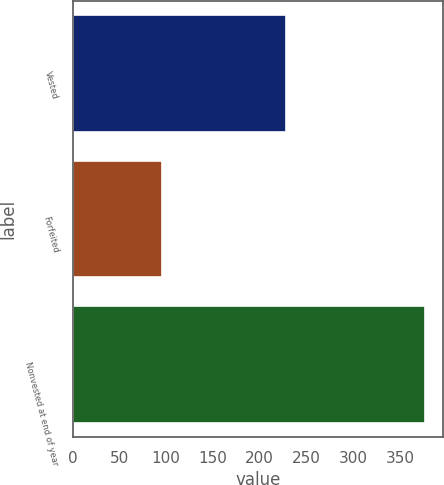Convert chart. <chart><loc_0><loc_0><loc_500><loc_500><bar_chart><fcel>Vested<fcel>Forfeited<fcel>Nonvested at end of year<nl><fcel>228<fcel>96<fcel>377<nl></chart> 